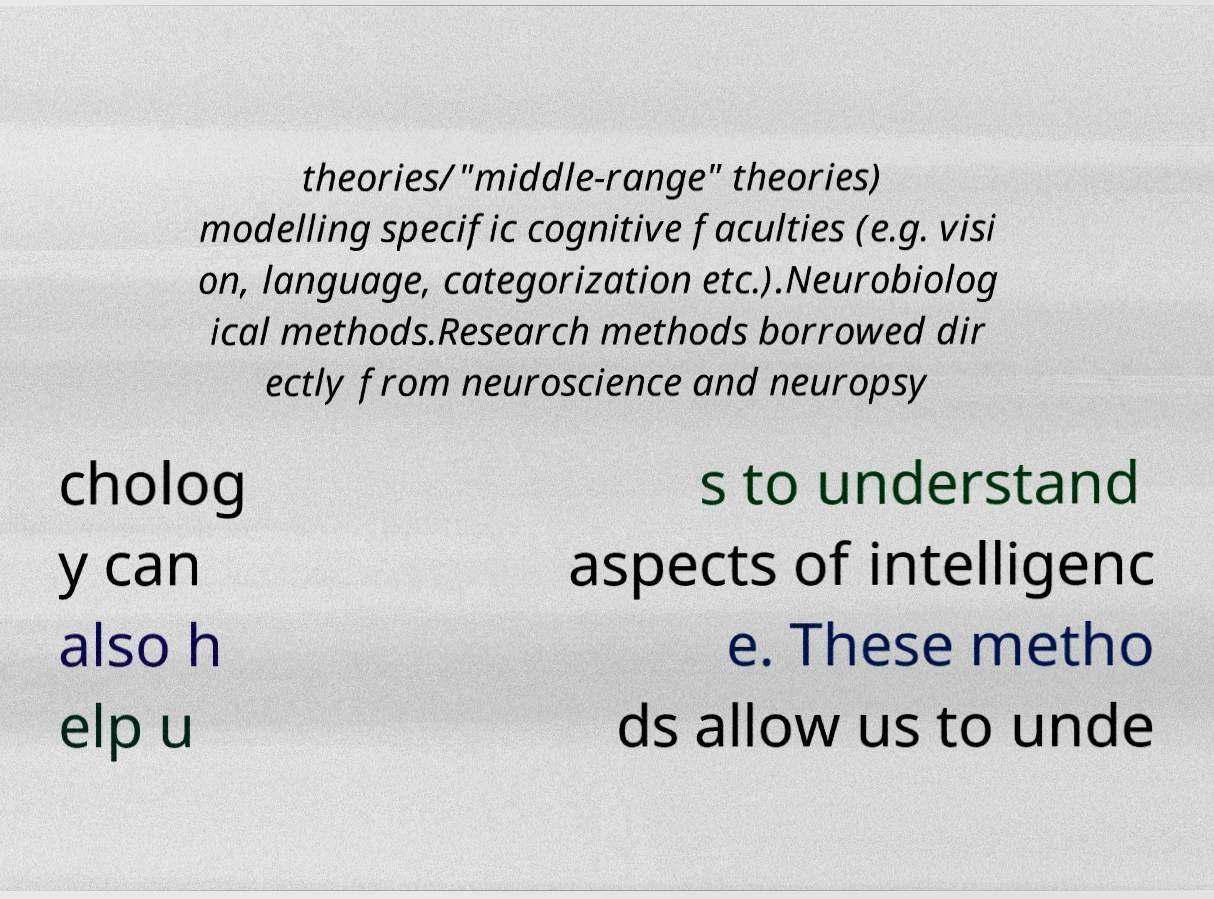Please identify and transcribe the text found in this image. theories/"middle-range" theories) modelling specific cognitive faculties (e.g. visi on, language, categorization etc.).Neurobiolog ical methods.Research methods borrowed dir ectly from neuroscience and neuropsy cholog y can also h elp u s to understand aspects of intelligenc e. These metho ds allow us to unde 